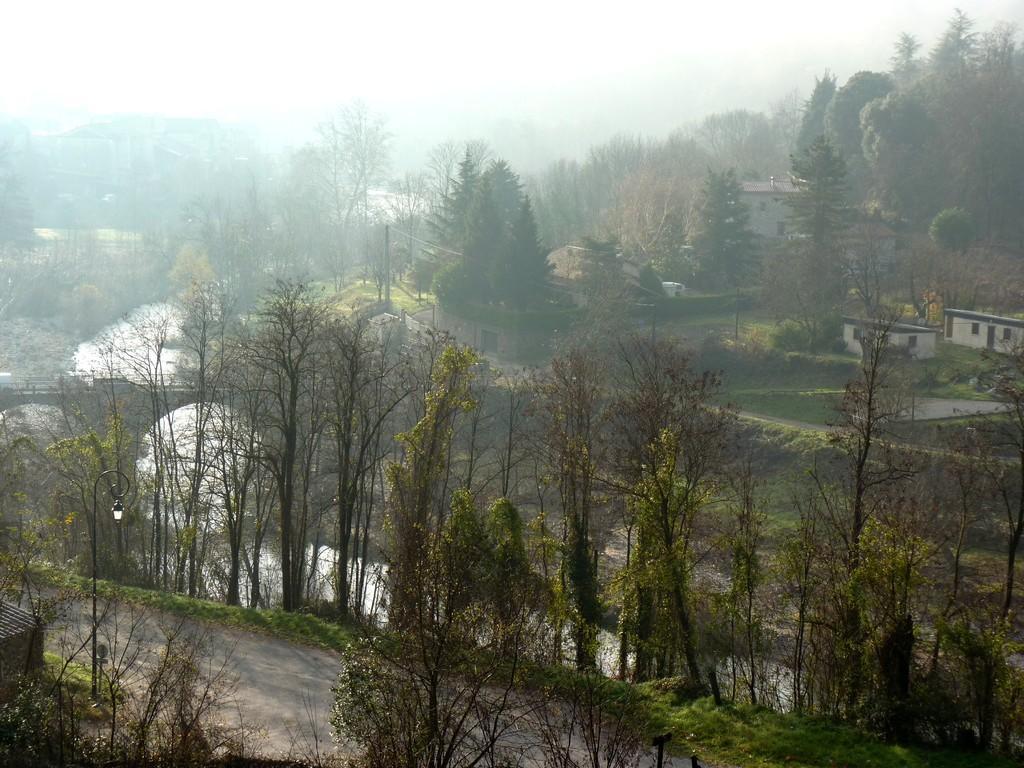In one or two sentences, can you explain what this image depicts? At the bottom of the picture, we see trees, road and a light pole. In the middle of the picture, we see the arch bridge and water. This water might be in the lake. There are trees and buildings in the background. At the top, we see the sky. 